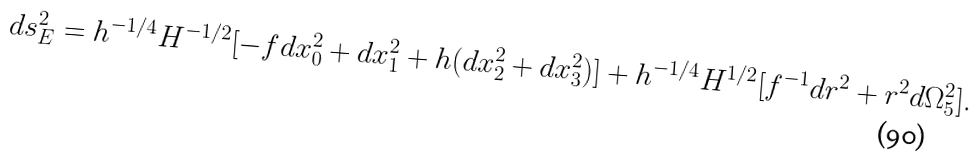Convert formula to latex. <formula><loc_0><loc_0><loc_500><loc_500>d s _ { E } ^ { 2 } = h ^ { - 1 / 4 } H ^ { - 1 / 2 } [ - f d x _ { 0 } ^ { 2 } + d x _ { 1 } ^ { 2 } + h ( d x _ { 2 } ^ { 2 } + d x _ { 3 } ^ { 2 } ) ] + h ^ { - 1 / 4 } H ^ { 1 / 2 } [ f ^ { - 1 } d r ^ { 2 } + r ^ { 2 } d \Omega _ { 5 } ^ { 2 } ] .</formula> 